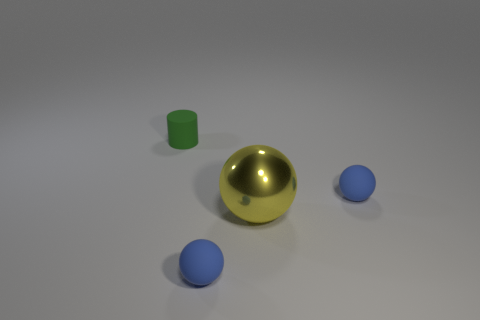How many spheres are either tiny rubber objects or blue rubber objects?
Provide a short and direct response. 2. There is a green thing behind the large yellow object; is its shape the same as the small blue object to the left of the large metal thing?
Provide a succinct answer. No. There is a small matte thing that is left of the large yellow metallic object and behind the yellow thing; what is its color?
Offer a very short reply. Green. There is a cylinder; is its color the same as the rubber sphere that is in front of the shiny object?
Provide a succinct answer. No. There is a matte object that is both behind the yellow sphere and left of the yellow shiny ball; how big is it?
Provide a short and direct response. Small. What number of other things are the same color as the metallic thing?
Ensure brevity in your answer.  0. There is a rubber cylinder that is behind the matte sphere in front of the small blue ball right of the big sphere; how big is it?
Make the answer very short. Small. Are there any tiny things in front of the yellow metallic object?
Offer a terse response. Yes. Do the green rubber cylinder and the blue sphere to the right of the shiny thing have the same size?
Keep it short and to the point. Yes. What number of other things are there of the same material as the large ball
Provide a short and direct response. 0. 